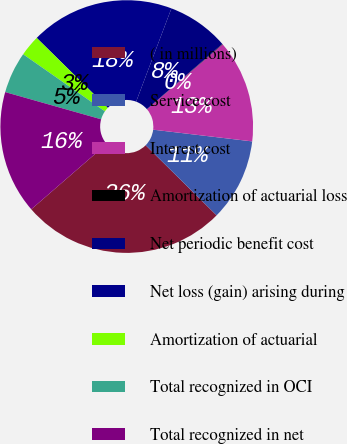Convert chart. <chart><loc_0><loc_0><loc_500><loc_500><pie_chart><fcel>( in millions)<fcel>Service cost<fcel>Interest cost<fcel>Amortization of actuarial loss<fcel>Net periodic benefit cost<fcel>Net loss (gain) arising during<fcel>Amortization of actuarial<fcel>Total recognized in OCI<fcel>Total recognized in net<nl><fcel>26.23%<fcel>10.53%<fcel>13.15%<fcel>0.06%<fcel>7.91%<fcel>18.38%<fcel>2.68%<fcel>5.3%<fcel>15.76%<nl></chart> 